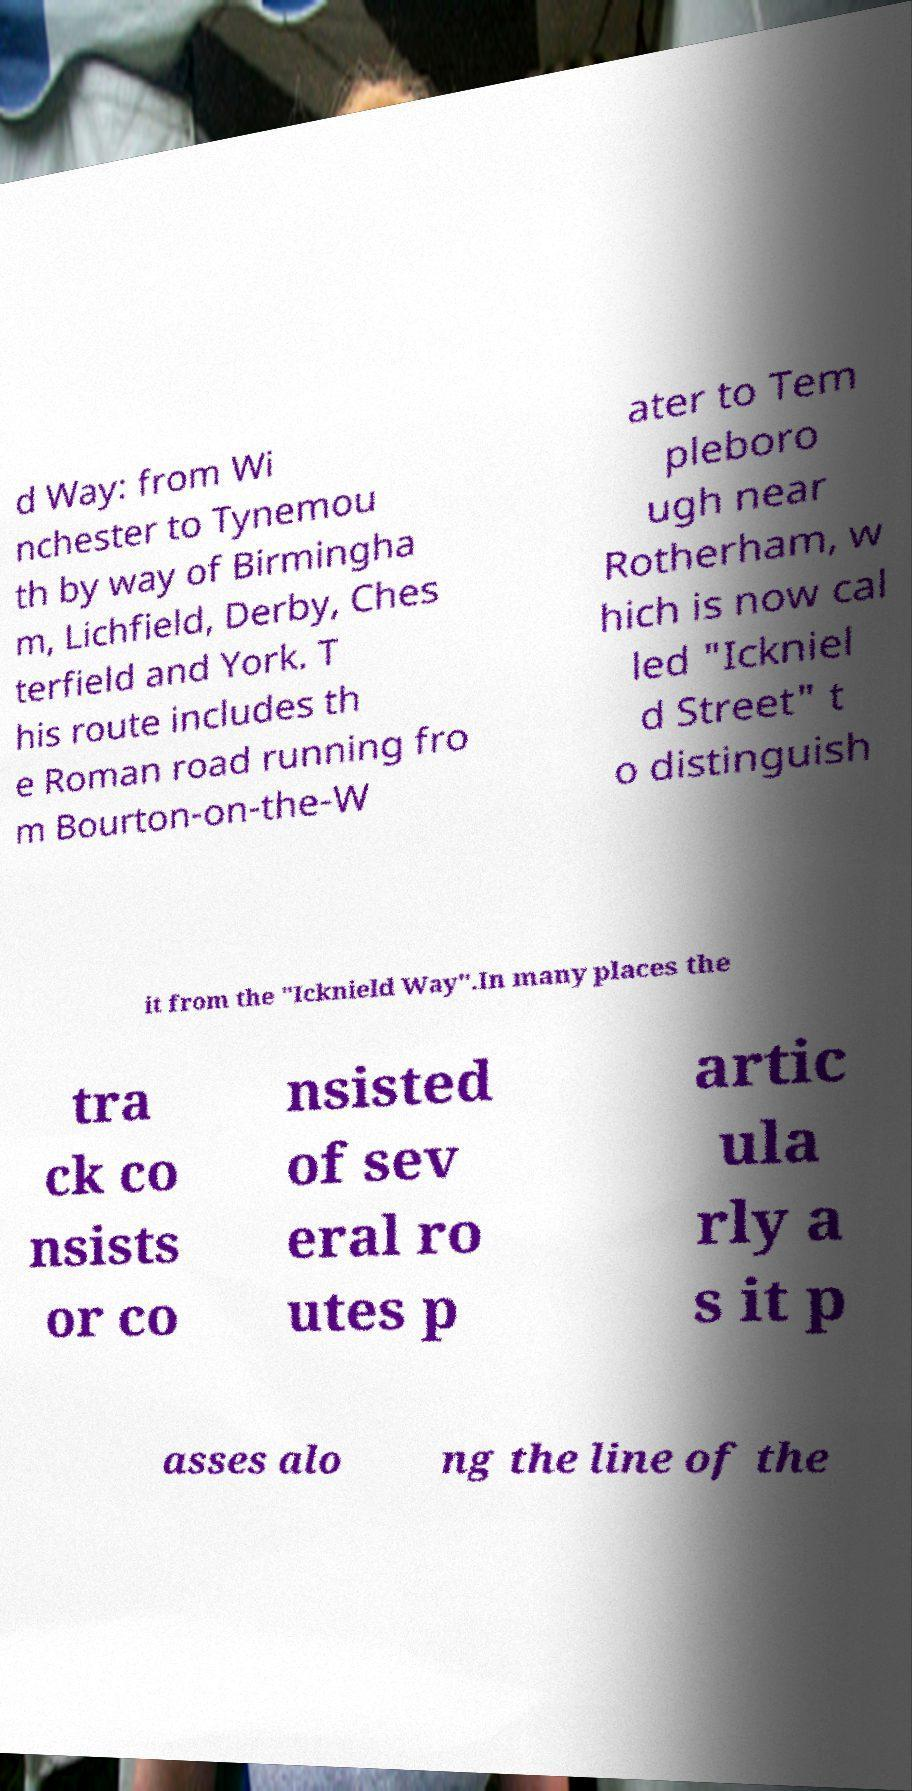Can you accurately transcribe the text from the provided image for me? d Way: from Wi nchester to Tynemou th by way of Birmingha m, Lichfield, Derby, Ches terfield and York. T his route includes th e Roman road running fro m Bourton-on-the-W ater to Tem pleboro ugh near Rotherham, w hich is now cal led "Ickniel d Street" t o distinguish it from the "Icknield Way".In many places the tra ck co nsists or co nsisted of sev eral ro utes p artic ula rly a s it p asses alo ng the line of the 